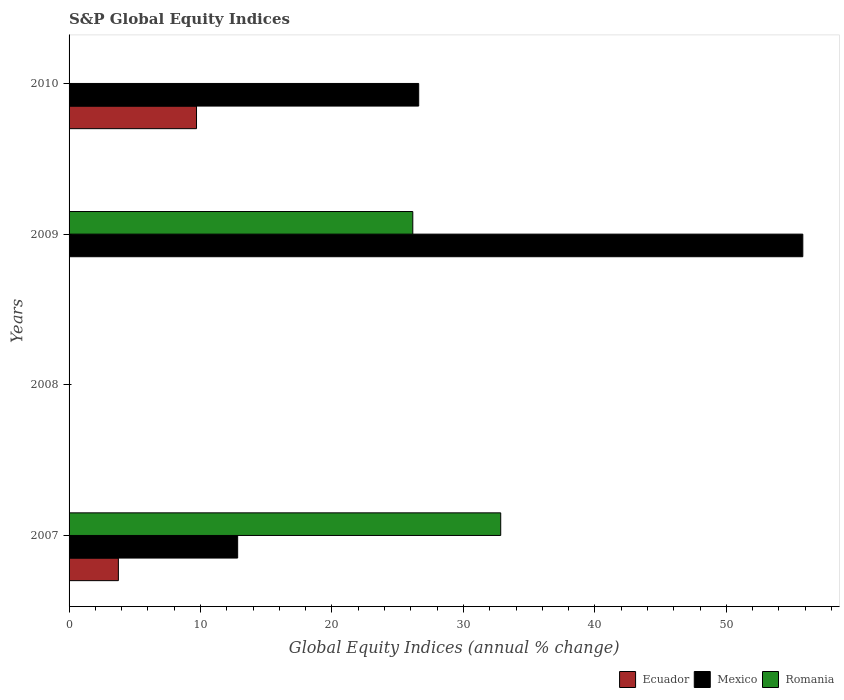Are the number of bars per tick equal to the number of legend labels?
Provide a short and direct response. No. Are the number of bars on each tick of the Y-axis equal?
Offer a very short reply. No. In how many cases, is the number of bars for a given year not equal to the number of legend labels?
Provide a short and direct response. 3. Across all years, what is the maximum global equity indices in Ecuador?
Give a very brief answer. 9.69. What is the total global equity indices in Ecuador in the graph?
Your answer should be very brief. 13.45. What is the difference between the global equity indices in Romania in 2007 and that in 2009?
Your response must be concise. 6.69. What is the difference between the global equity indices in Mexico in 2009 and the global equity indices in Ecuador in 2008?
Your response must be concise. 55.81. What is the average global equity indices in Mexico per year?
Your response must be concise. 23.81. In the year 2007, what is the difference between the global equity indices in Mexico and global equity indices in Romania?
Your response must be concise. -20.01. What is the ratio of the global equity indices in Romania in 2007 to that in 2009?
Provide a succinct answer. 1.26. Is the global equity indices in Mexico in 2007 less than that in 2009?
Your answer should be very brief. Yes. Is the difference between the global equity indices in Mexico in 2007 and 2009 greater than the difference between the global equity indices in Romania in 2007 and 2009?
Your answer should be very brief. No. What is the difference between the highest and the second highest global equity indices in Mexico?
Your answer should be very brief. 29.22. What is the difference between the highest and the lowest global equity indices in Romania?
Make the answer very short. 32.84. Is it the case that in every year, the sum of the global equity indices in Romania and global equity indices in Mexico is greater than the global equity indices in Ecuador?
Make the answer very short. No. Are all the bars in the graph horizontal?
Your answer should be very brief. Yes. Are the values on the major ticks of X-axis written in scientific E-notation?
Ensure brevity in your answer.  No. Where does the legend appear in the graph?
Make the answer very short. Bottom right. How are the legend labels stacked?
Make the answer very short. Horizontal. What is the title of the graph?
Keep it short and to the point. S&P Global Equity Indices. Does "Malta" appear as one of the legend labels in the graph?
Your response must be concise. No. What is the label or title of the X-axis?
Your answer should be compact. Global Equity Indices (annual % change). What is the label or title of the Y-axis?
Offer a very short reply. Years. What is the Global Equity Indices (annual % change) of Ecuador in 2007?
Offer a terse response. 3.75. What is the Global Equity Indices (annual % change) in Mexico in 2007?
Your answer should be very brief. 12.82. What is the Global Equity Indices (annual % change) in Romania in 2007?
Make the answer very short. 32.84. What is the Global Equity Indices (annual % change) of Mexico in 2008?
Your answer should be very brief. 0. What is the Global Equity Indices (annual % change) in Romania in 2008?
Provide a short and direct response. 0. What is the Global Equity Indices (annual % change) of Ecuador in 2009?
Offer a very short reply. 0. What is the Global Equity Indices (annual % change) in Mexico in 2009?
Give a very brief answer. 55.81. What is the Global Equity Indices (annual % change) in Romania in 2009?
Offer a terse response. 26.15. What is the Global Equity Indices (annual % change) in Ecuador in 2010?
Offer a terse response. 9.69. What is the Global Equity Indices (annual % change) of Mexico in 2010?
Offer a very short reply. 26.6. What is the Global Equity Indices (annual % change) in Romania in 2010?
Provide a short and direct response. 0. Across all years, what is the maximum Global Equity Indices (annual % change) in Ecuador?
Make the answer very short. 9.69. Across all years, what is the maximum Global Equity Indices (annual % change) in Mexico?
Provide a short and direct response. 55.81. Across all years, what is the maximum Global Equity Indices (annual % change) of Romania?
Offer a very short reply. 32.84. Across all years, what is the minimum Global Equity Indices (annual % change) in Mexico?
Your answer should be compact. 0. What is the total Global Equity Indices (annual % change) of Ecuador in the graph?
Give a very brief answer. 13.45. What is the total Global Equity Indices (annual % change) in Mexico in the graph?
Provide a succinct answer. 95.23. What is the total Global Equity Indices (annual % change) in Romania in the graph?
Offer a very short reply. 58.98. What is the difference between the Global Equity Indices (annual % change) in Mexico in 2007 and that in 2009?
Provide a succinct answer. -42.99. What is the difference between the Global Equity Indices (annual % change) of Romania in 2007 and that in 2009?
Your answer should be very brief. 6.69. What is the difference between the Global Equity Indices (annual % change) of Ecuador in 2007 and that in 2010?
Your response must be concise. -5.94. What is the difference between the Global Equity Indices (annual % change) in Mexico in 2007 and that in 2010?
Make the answer very short. -13.77. What is the difference between the Global Equity Indices (annual % change) of Mexico in 2009 and that in 2010?
Make the answer very short. 29.22. What is the difference between the Global Equity Indices (annual % change) in Ecuador in 2007 and the Global Equity Indices (annual % change) in Mexico in 2009?
Give a very brief answer. -52.06. What is the difference between the Global Equity Indices (annual % change) of Ecuador in 2007 and the Global Equity Indices (annual % change) of Romania in 2009?
Make the answer very short. -22.4. What is the difference between the Global Equity Indices (annual % change) in Mexico in 2007 and the Global Equity Indices (annual % change) in Romania in 2009?
Your answer should be very brief. -13.32. What is the difference between the Global Equity Indices (annual % change) in Ecuador in 2007 and the Global Equity Indices (annual % change) in Mexico in 2010?
Offer a terse response. -22.84. What is the average Global Equity Indices (annual % change) in Ecuador per year?
Offer a very short reply. 3.36. What is the average Global Equity Indices (annual % change) in Mexico per year?
Ensure brevity in your answer.  23.81. What is the average Global Equity Indices (annual % change) of Romania per year?
Offer a terse response. 14.75. In the year 2007, what is the difference between the Global Equity Indices (annual % change) in Ecuador and Global Equity Indices (annual % change) in Mexico?
Your answer should be compact. -9.07. In the year 2007, what is the difference between the Global Equity Indices (annual % change) in Ecuador and Global Equity Indices (annual % change) in Romania?
Ensure brevity in your answer.  -29.08. In the year 2007, what is the difference between the Global Equity Indices (annual % change) in Mexico and Global Equity Indices (annual % change) in Romania?
Make the answer very short. -20.01. In the year 2009, what is the difference between the Global Equity Indices (annual % change) in Mexico and Global Equity Indices (annual % change) in Romania?
Provide a succinct answer. 29.67. In the year 2010, what is the difference between the Global Equity Indices (annual % change) in Ecuador and Global Equity Indices (annual % change) in Mexico?
Your answer should be compact. -16.9. What is the ratio of the Global Equity Indices (annual % change) in Mexico in 2007 to that in 2009?
Provide a short and direct response. 0.23. What is the ratio of the Global Equity Indices (annual % change) in Romania in 2007 to that in 2009?
Offer a very short reply. 1.26. What is the ratio of the Global Equity Indices (annual % change) in Ecuador in 2007 to that in 2010?
Your answer should be very brief. 0.39. What is the ratio of the Global Equity Indices (annual % change) in Mexico in 2007 to that in 2010?
Give a very brief answer. 0.48. What is the ratio of the Global Equity Indices (annual % change) of Mexico in 2009 to that in 2010?
Give a very brief answer. 2.1. What is the difference between the highest and the second highest Global Equity Indices (annual % change) of Mexico?
Offer a terse response. 29.22. What is the difference between the highest and the lowest Global Equity Indices (annual % change) in Ecuador?
Ensure brevity in your answer.  9.7. What is the difference between the highest and the lowest Global Equity Indices (annual % change) in Mexico?
Give a very brief answer. 55.81. What is the difference between the highest and the lowest Global Equity Indices (annual % change) in Romania?
Ensure brevity in your answer.  32.84. 